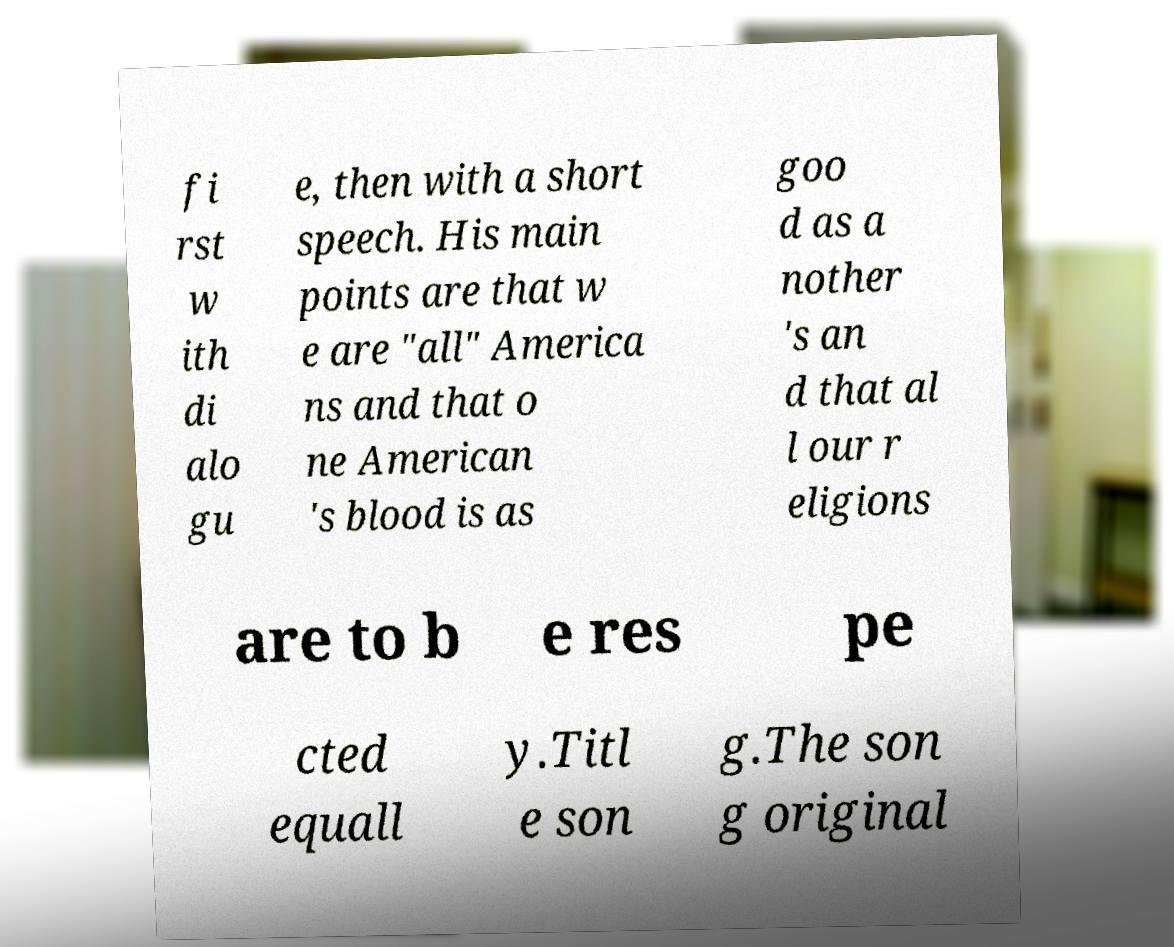I need the written content from this picture converted into text. Can you do that? fi rst w ith di alo gu e, then with a short speech. His main points are that w e are "all" America ns and that o ne American 's blood is as goo d as a nother 's an d that al l our r eligions are to b e res pe cted equall y.Titl e son g.The son g original 